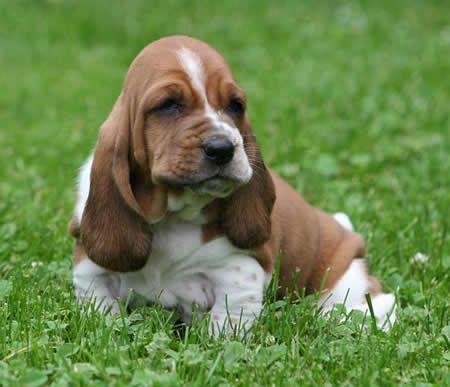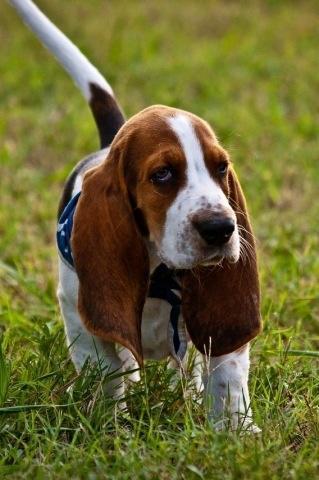The first image is the image on the left, the second image is the image on the right. Analyze the images presented: Is the assertion "A basset hound is showing its tongue in exactly one of the photos." valid? Answer yes or no. No. The first image is the image on the left, the second image is the image on the right. For the images displayed, is the sentence "A dogs tongue is sticking way out." factually correct? Answer yes or no. No. 